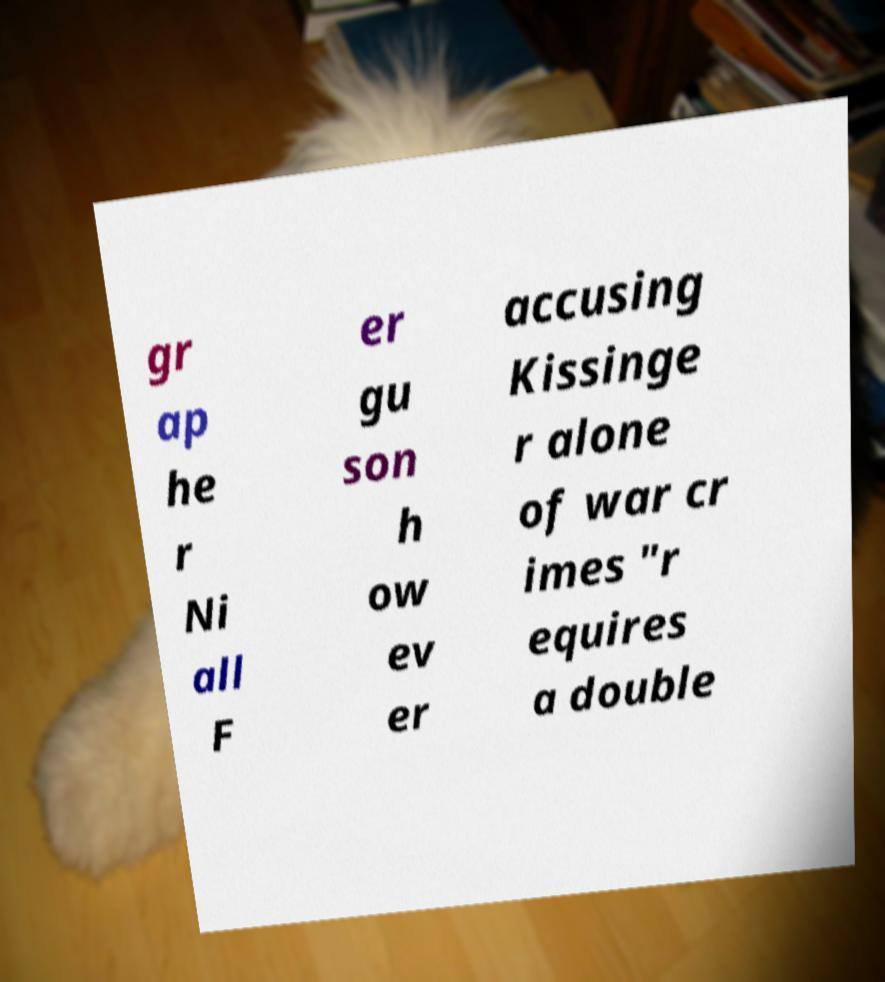Please read and relay the text visible in this image. What does it say? gr ap he r Ni all F er gu son h ow ev er accusing Kissinge r alone of war cr imes "r equires a double 